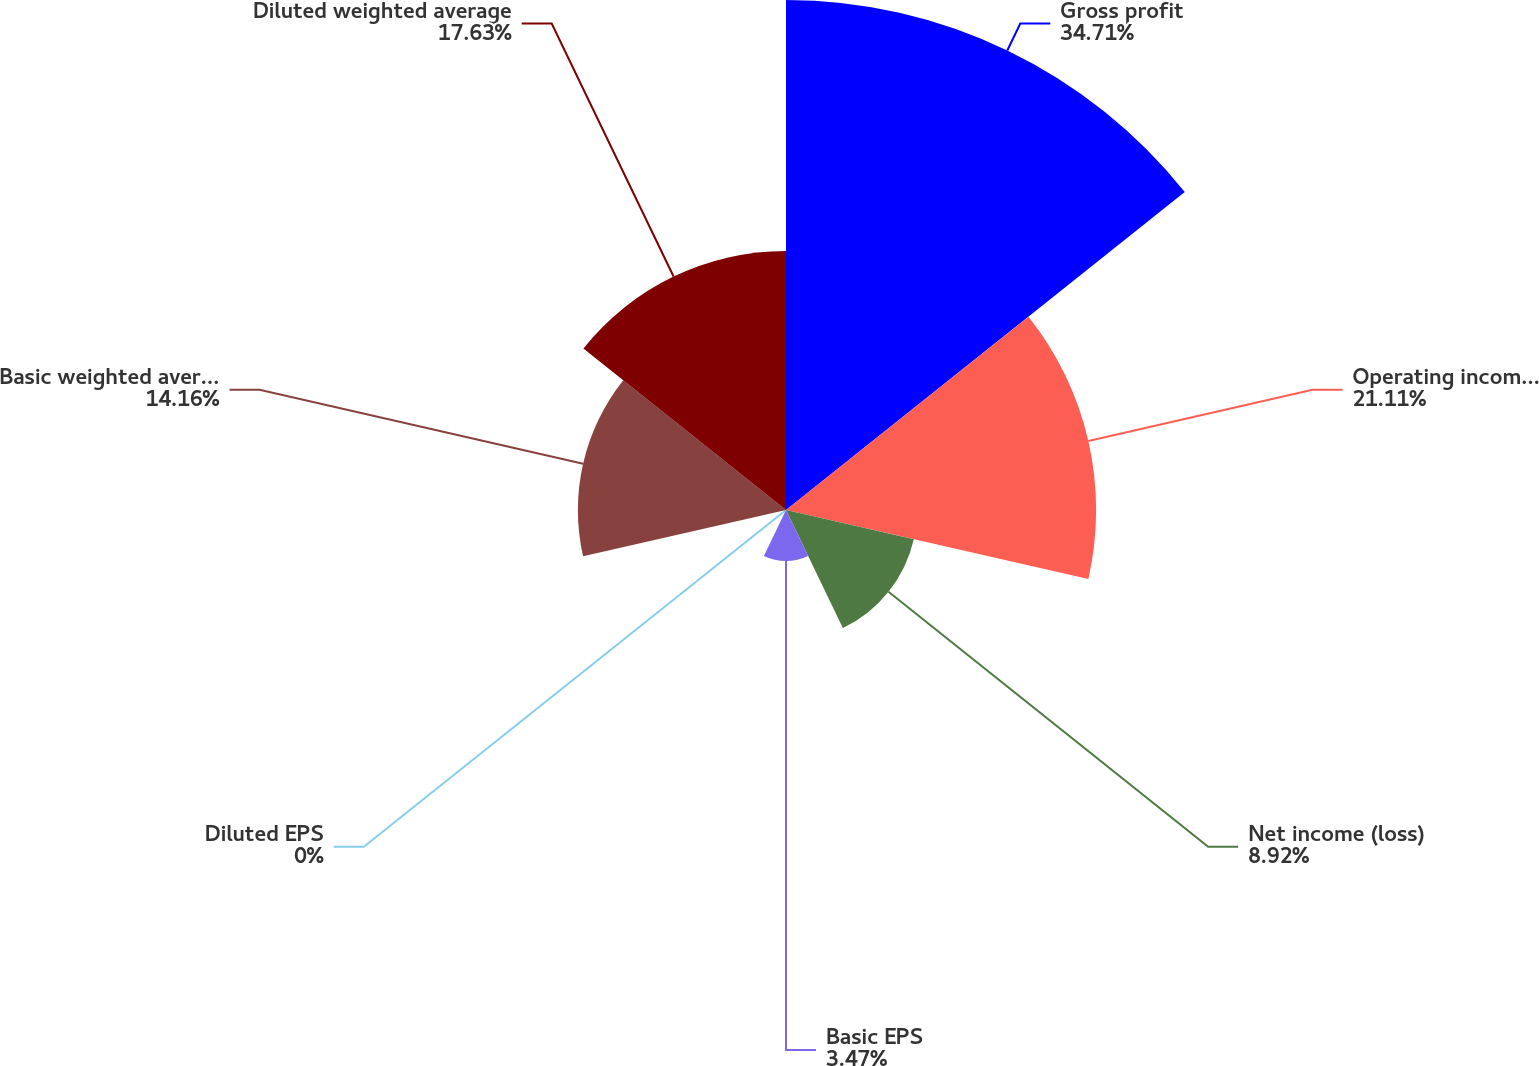Convert chart to OTSL. <chart><loc_0><loc_0><loc_500><loc_500><pie_chart><fcel>Gross profit<fcel>Operating income (loss)<fcel>Net income (loss)<fcel>Basic EPS<fcel>Diluted EPS<fcel>Basic weighted average shares<fcel>Diluted weighted average<nl><fcel>34.7%<fcel>21.1%<fcel>8.92%<fcel>3.47%<fcel>0.0%<fcel>14.16%<fcel>17.63%<nl></chart> 